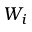<formula> <loc_0><loc_0><loc_500><loc_500>W _ { i }</formula> 